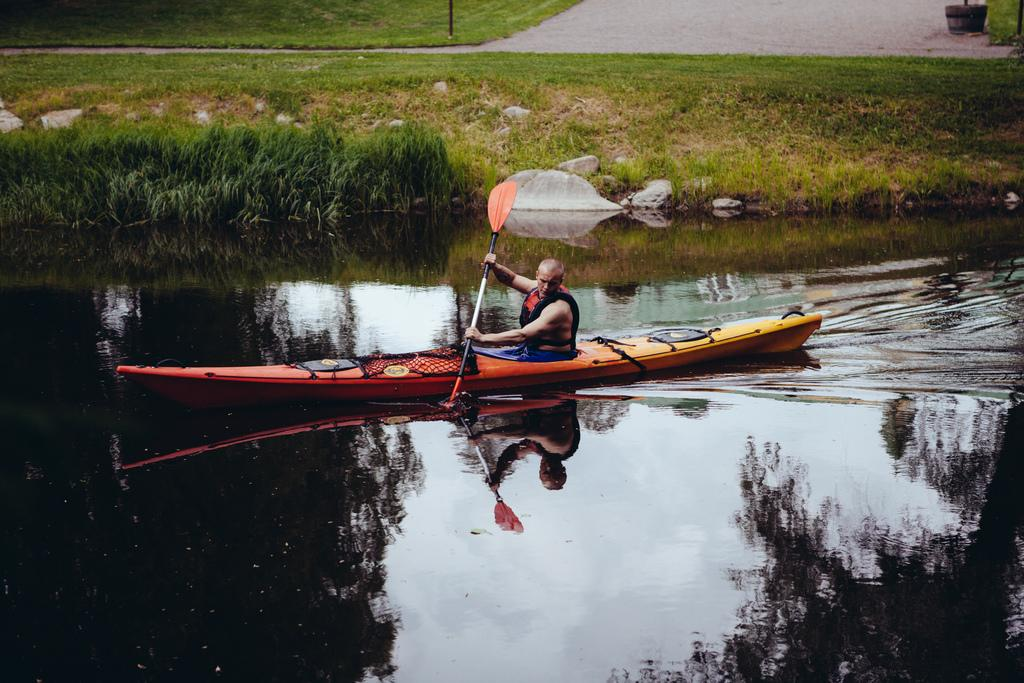What is the man in the image doing? The man is paddling in a lake. What type of natural environment can be seen in the image? There is a garden visible in the image. What type of vegetation is present in the image? There is grass in the image. What type of man-made structure is present in the image? There is a road in the image. What type of tool is the carpenter using in the image? There is no carpenter or tool present in the image. How many hands does the man have in the image? The image does not show the man's hands, so it is impossible to determine the number of hands he has. 